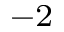Convert formula to latex. <formula><loc_0><loc_0><loc_500><loc_500>^ { - 2 }</formula> 